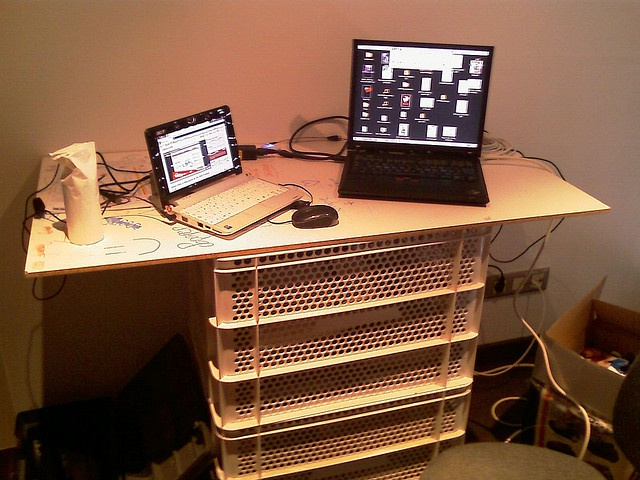Describe the objects in this image and their specific colors. I can see laptop in olive, black, white, purple, and maroon tones, laptop in olive, white, tan, and black tones, chair in olive, black, and maroon tones, keyboard in olive, tan, and beige tones, and keyboard in black and olive tones in this image. 